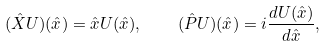Convert formula to latex. <formula><loc_0><loc_0><loc_500><loc_500>( \hat { X } U ) ( \hat { x } ) = \hat { x } U ( \hat { x } ) , \quad ( \hat { P } U ) ( \hat { x } ) = i \frac { d U ( \hat { x } ) } { d \hat { x } } ,</formula> 